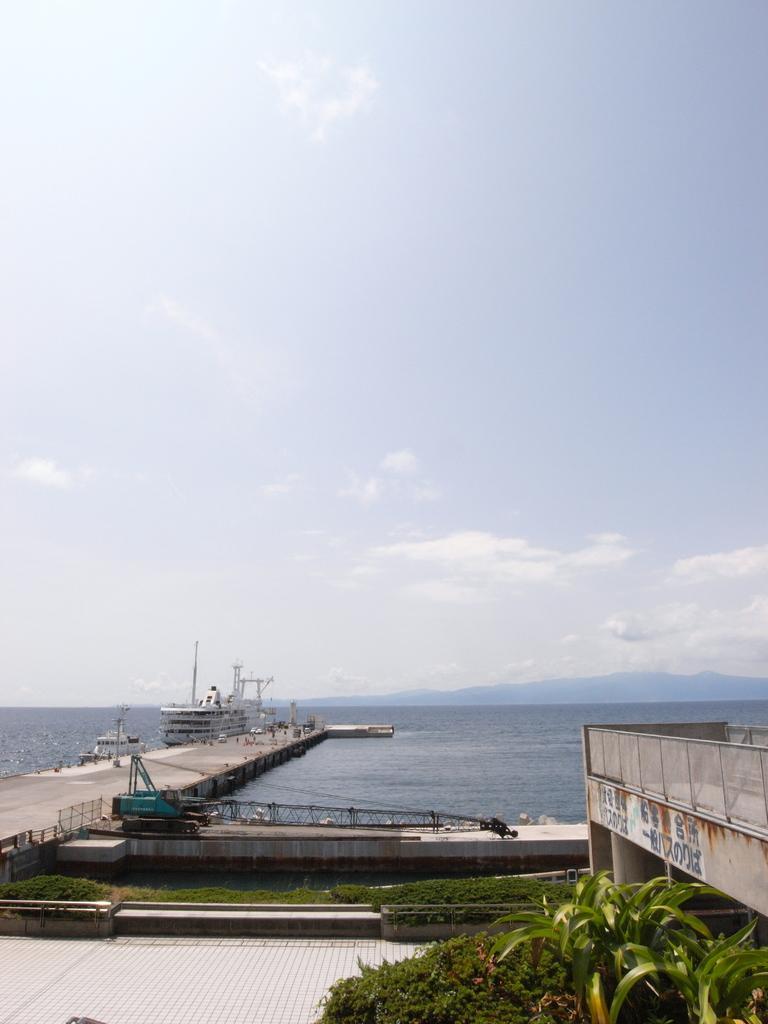Could you give a brief overview of what you see in this image? In this image we see the ships, bride, fence on the left side, on the right we can see bridge railing, plants, grass, at the bottom we can see the floor, at the top we can see the hills and the sky with clouds. 